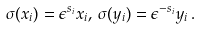<formula> <loc_0><loc_0><loc_500><loc_500>\sigma ( x _ { i } ) = \epsilon ^ { s _ { i } } x _ { i } , \, \sigma ( y _ { i } ) = \epsilon ^ { - s _ { i } } y _ { i } \, .</formula> 